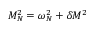Convert formula to latex. <formula><loc_0><loc_0><loc_500><loc_500>M _ { N } ^ { 2 } = \omega _ { N } ^ { 2 } + \delta M ^ { 2 }</formula> 